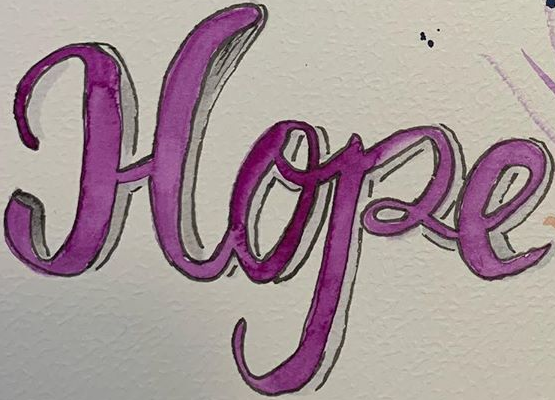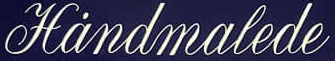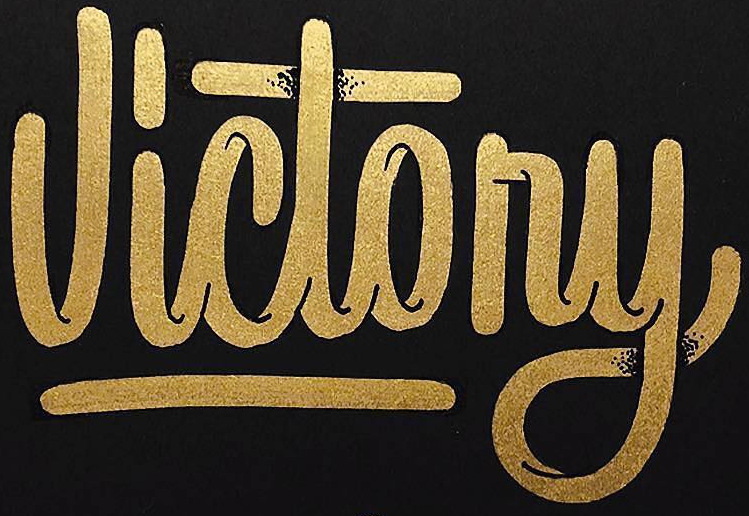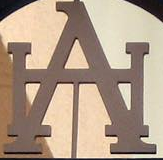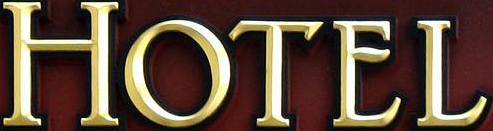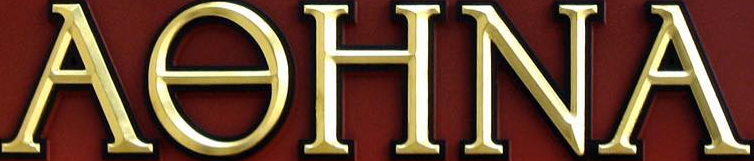Read the text from these images in sequence, separated by a semicolon. Hope; Hȧndmalede; Victony; HA; HOTEL; AƟHNA 